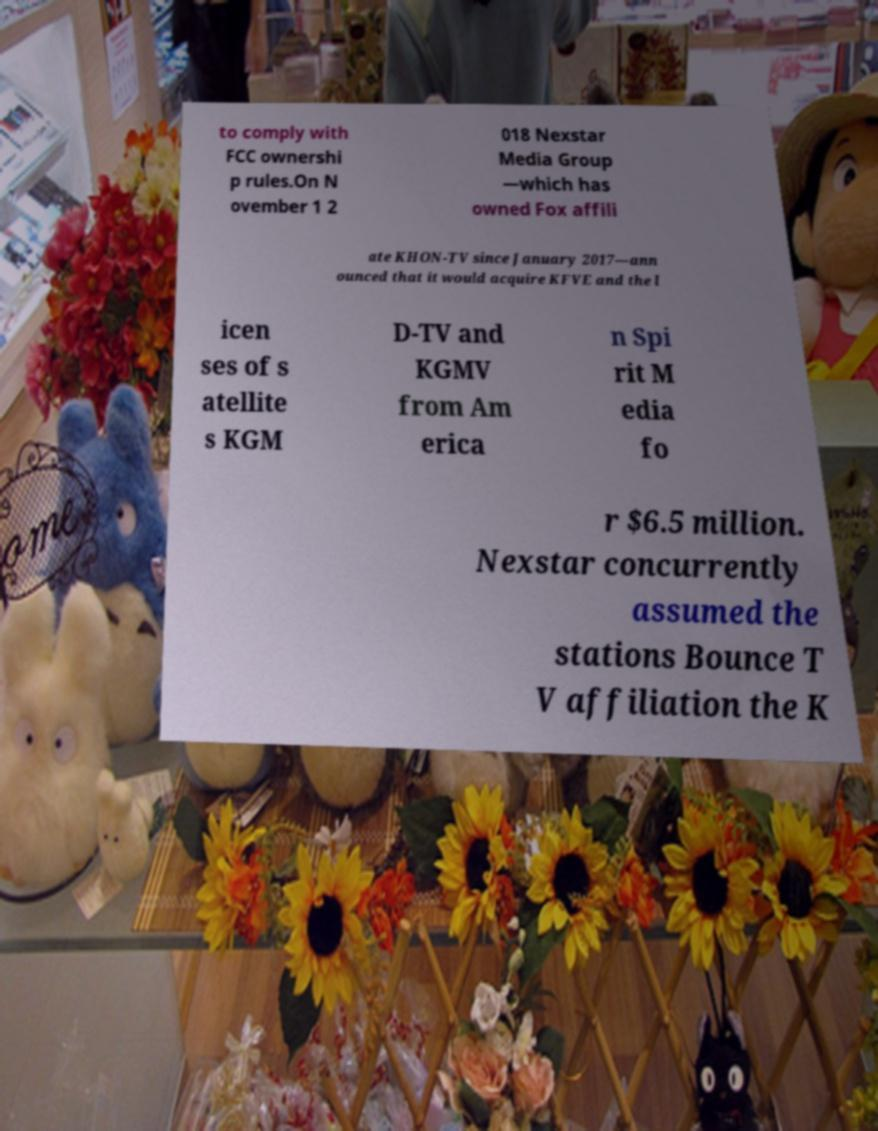There's text embedded in this image that I need extracted. Can you transcribe it verbatim? to comply with FCC ownershi p rules.On N ovember 1 2 018 Nexstar Media Group —which has owned Fox affili ate KHON-TV since January 2017—ann ounced that it would acquire KFVE and the l icen ses of s atellite s KGM D-TV and KGMV from Am erica n Spi rit M edia fo r $6.5 million. Nexstar concurrently assumed the stations Bounce T V affiliation the K 